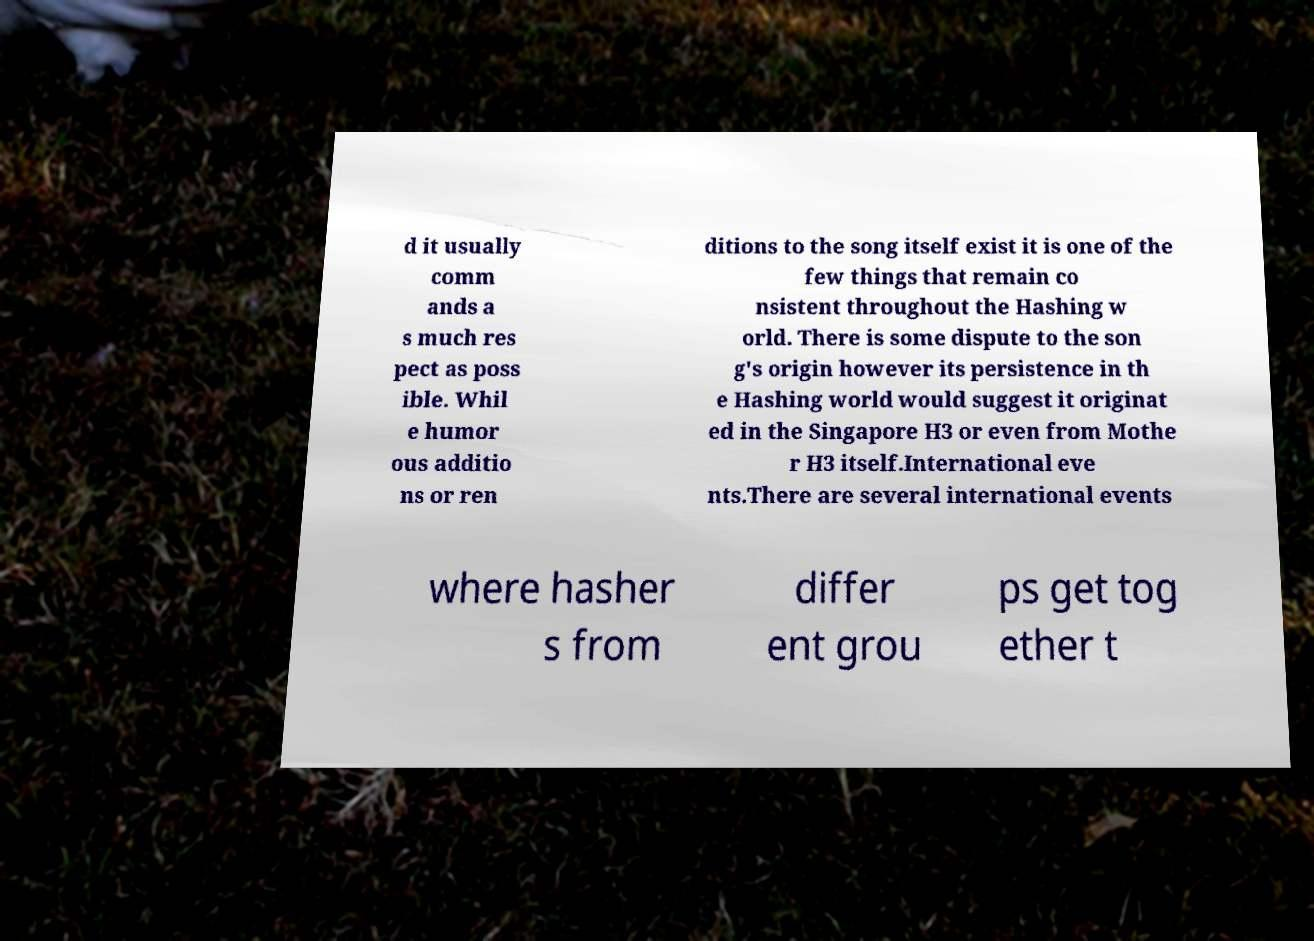For documentation purposes, I need the text within this image transcribed. Could you provide that? d it usually comm ands a s much res pect as poss ible. Whil e humor ous additio ns or ren ditions to the song itself exist it is one of the few things that remain co nsistent throughout the Hashing w orld. There is some dispute to the son g's origin however its persistence in th e Hashing world would suggest it originat ed in the Singapore H3 or even from Mothe r H3 itself.International eve nts.There are several international events where hasher s from differ ent grou ps get tog ether t 